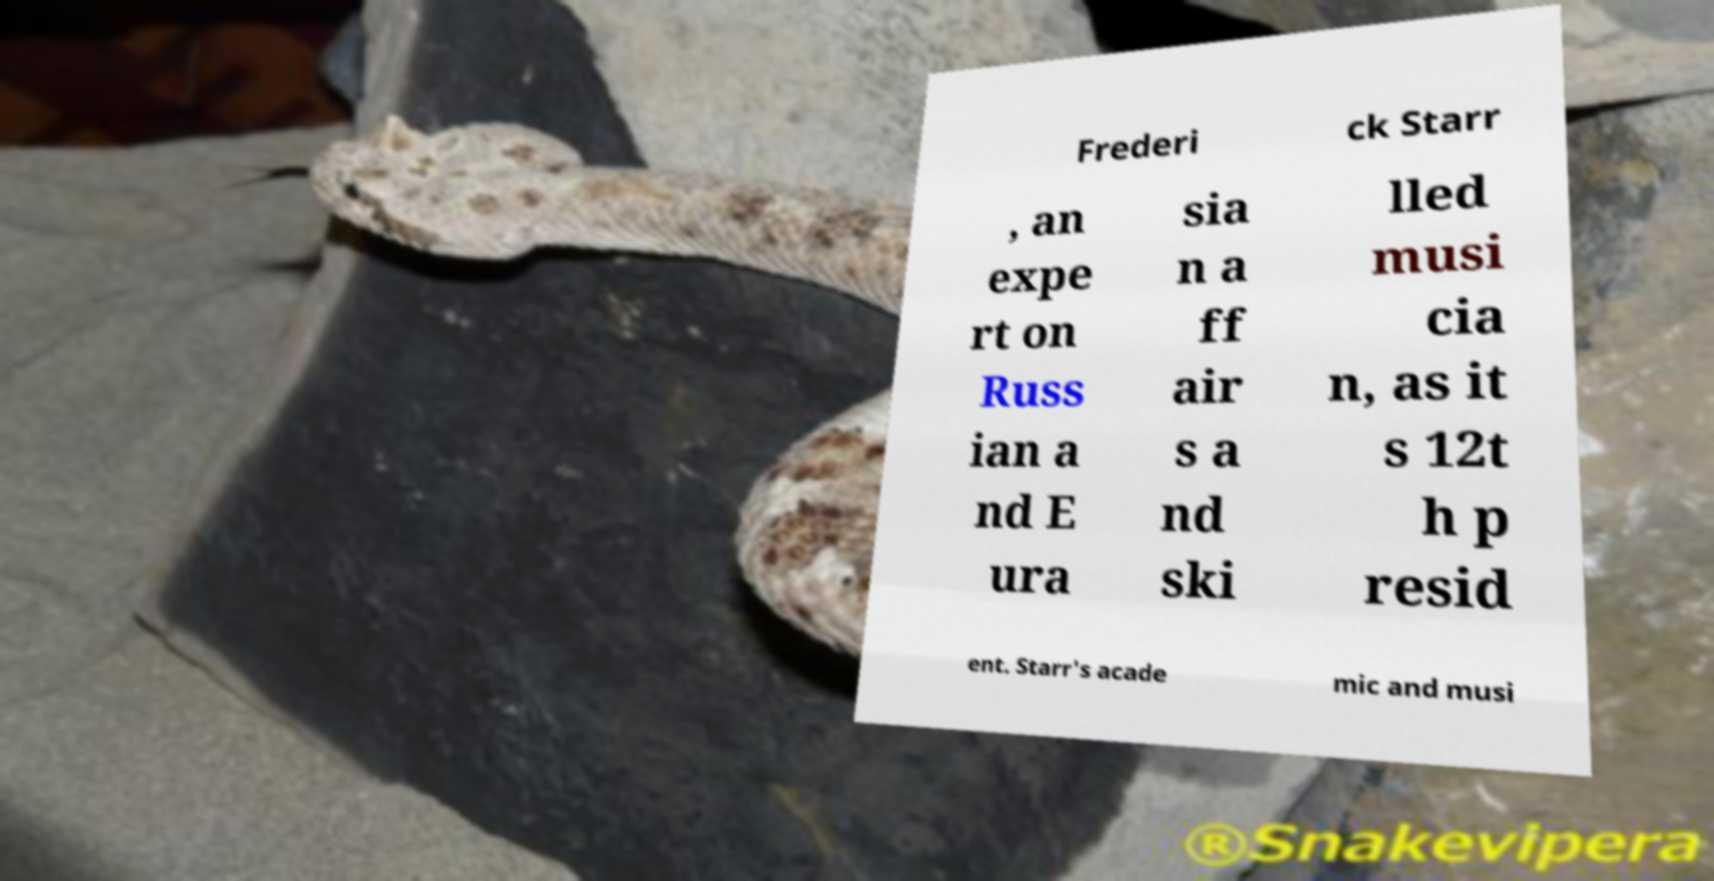There's text embedded in this image that I need extracted. Can you transcribe it verbatim? Frederi ck Starr , an expe rt on Russ ian a nd E ura sia n a ff air s a nd ski lled musi cia n, as it s 12t h p resid ent. Starr's acade mic and musi 